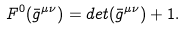<formula> <loc_0><loc_0><loc_500><loc_500>F ^ { 0 } ( \bar { g } ^ { \mu \nu } ) = d e t ( \bar { g } ^ { \mu \nu } ) + 1 .</formula> 